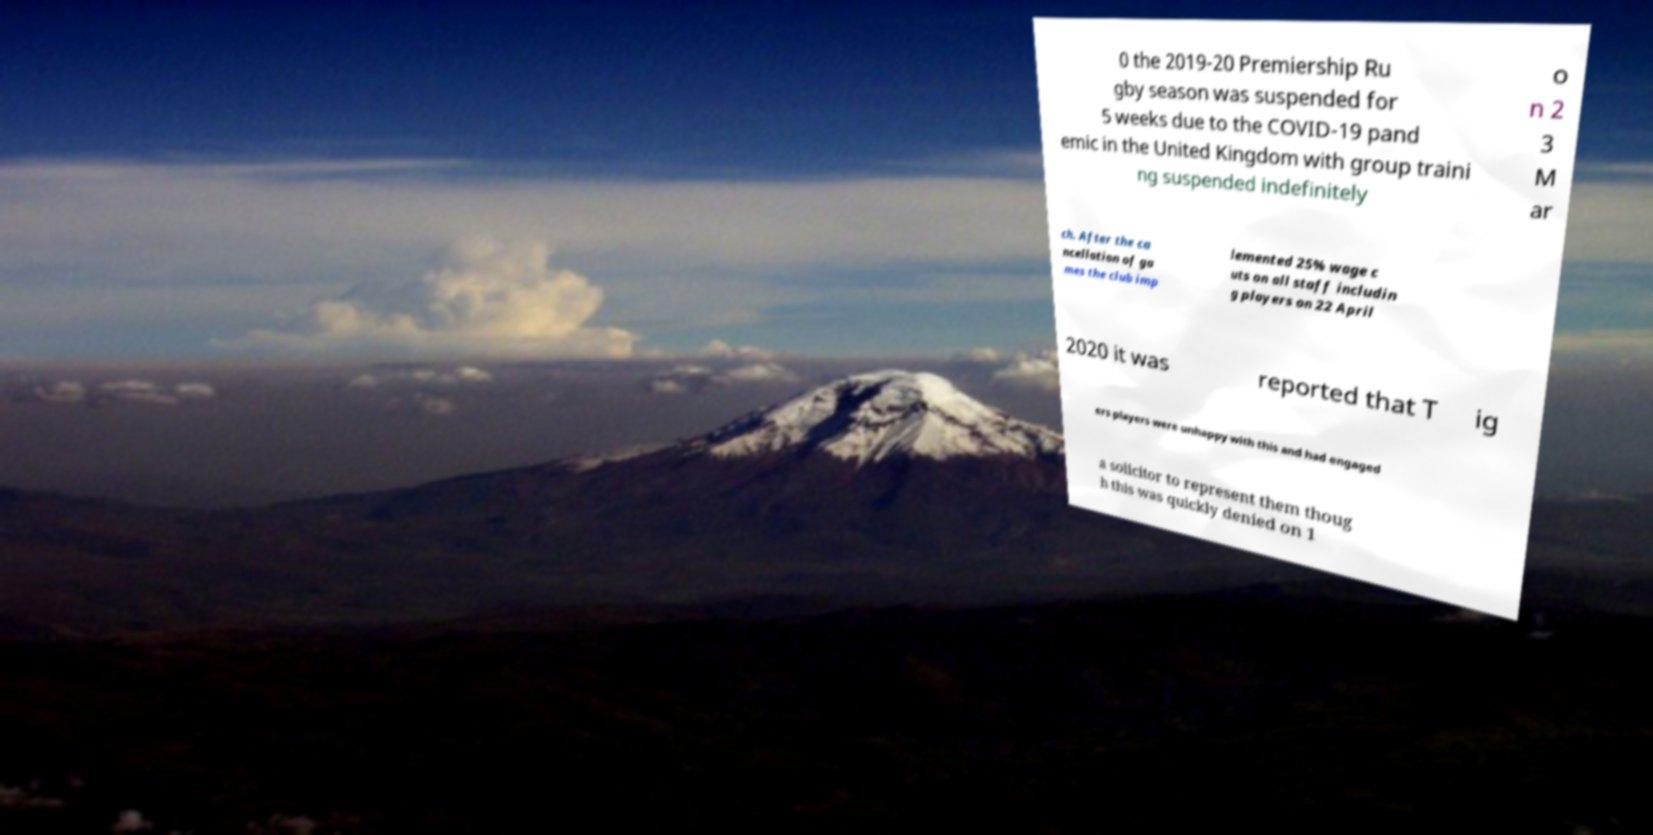Can you accurately transcribe the text from the provided image for me? 0 the 2019-20 Premiership Ru gby season was suspended for 5 weeks due to the COVID-19 pand emic in the United Kingdom with group traini ng suspended indefinitely o n 2 3 M ar ch. After the ca ncellation of ga mes the club imp lemented 25% wage c uts on all staff includin g players on 22 April 2020 it was reported that T ig ers players were unhappy with this and had engaged a solicitor to represent them thoug h this was quickly denied on 1 